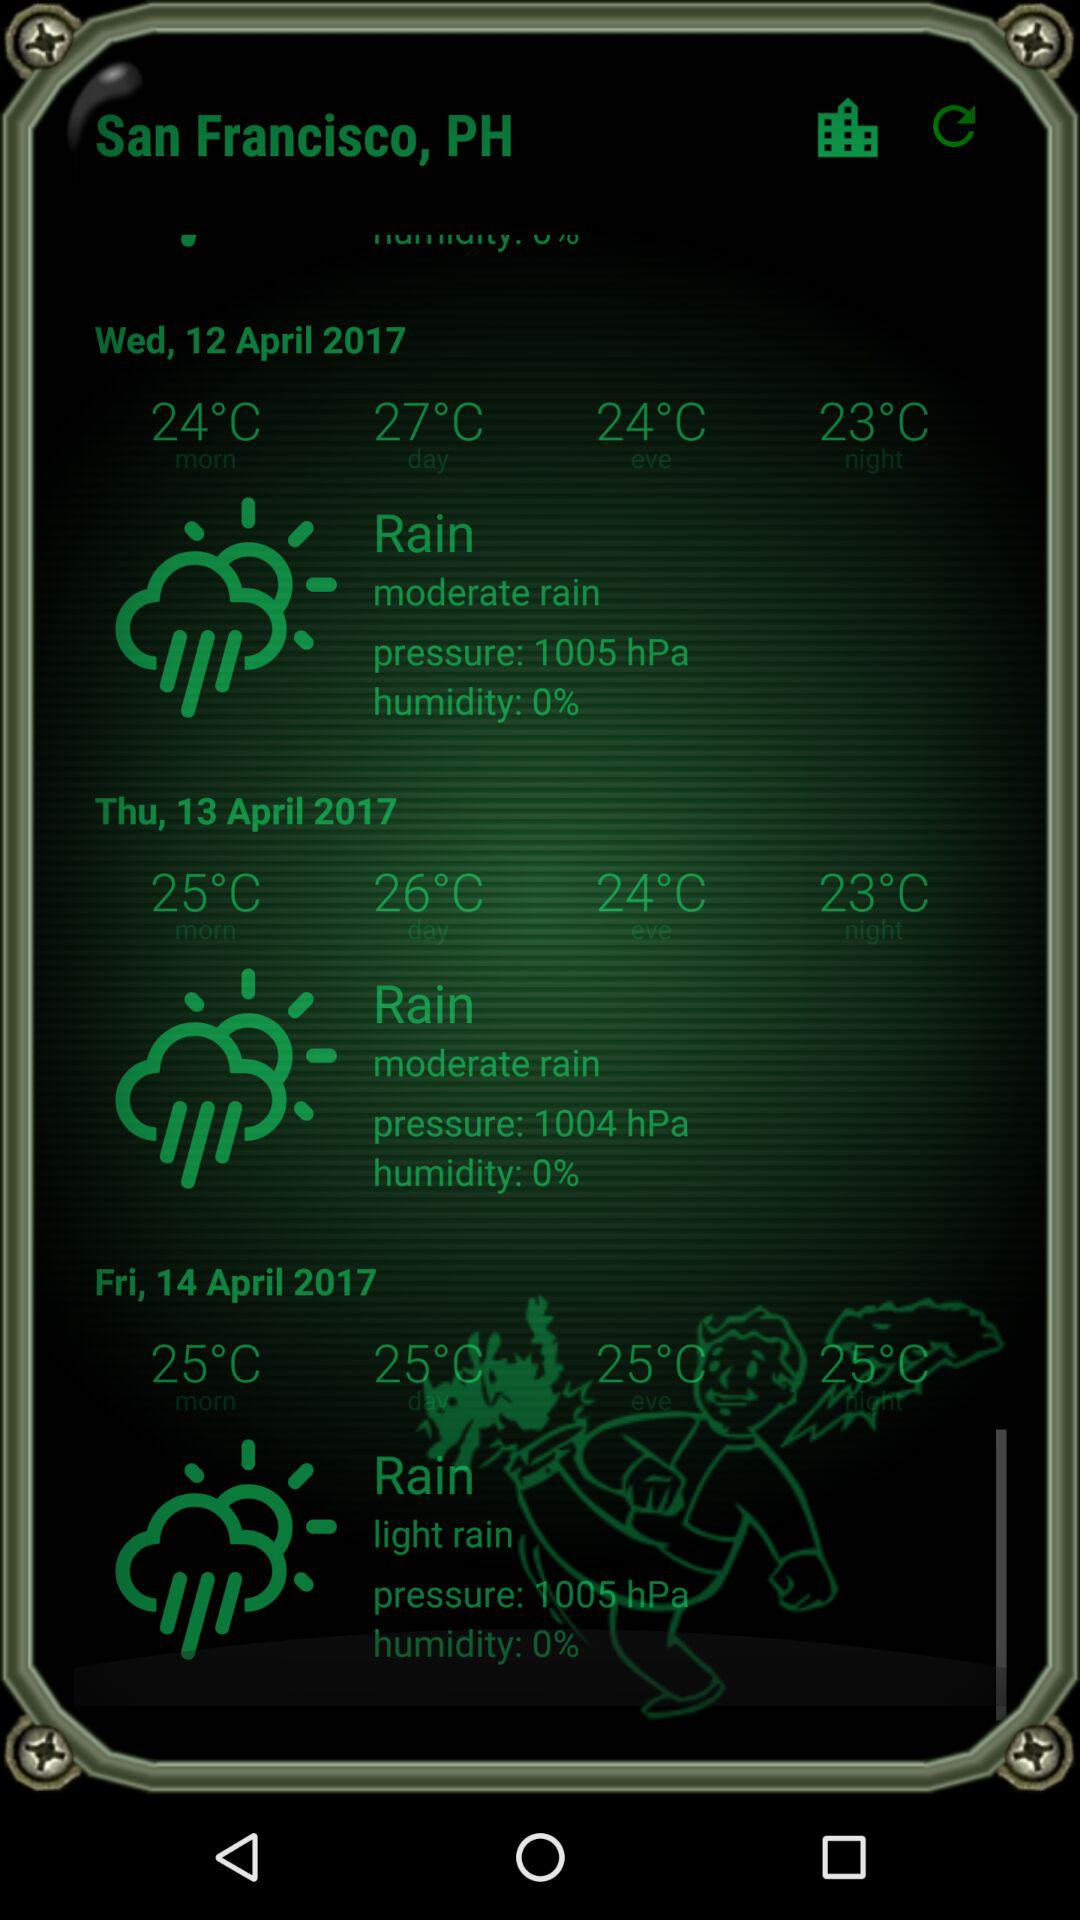How’s the weather on April 12, 2017? The weather on April 12, 2017 is moderately rainy. 